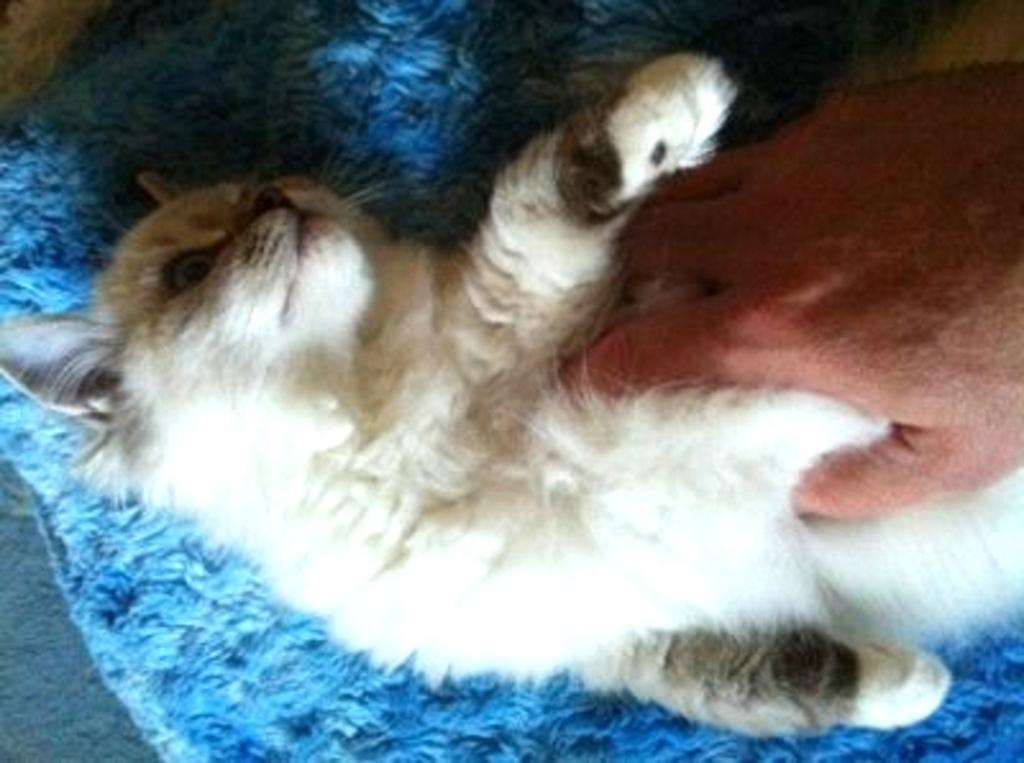What type of animal is in the image? There is a cat in the image. Can you describe the color pattern of the cat? The cat is white and black in color. What is the cat sitting on in the image? The cat is on a blue mat. Who is holding the cat in the image? There is a person holding the cat. What type of wax is being used to create the coil in the image? There is no wax or coil present in the image; it features a cat on a blue mat being held by a person. 